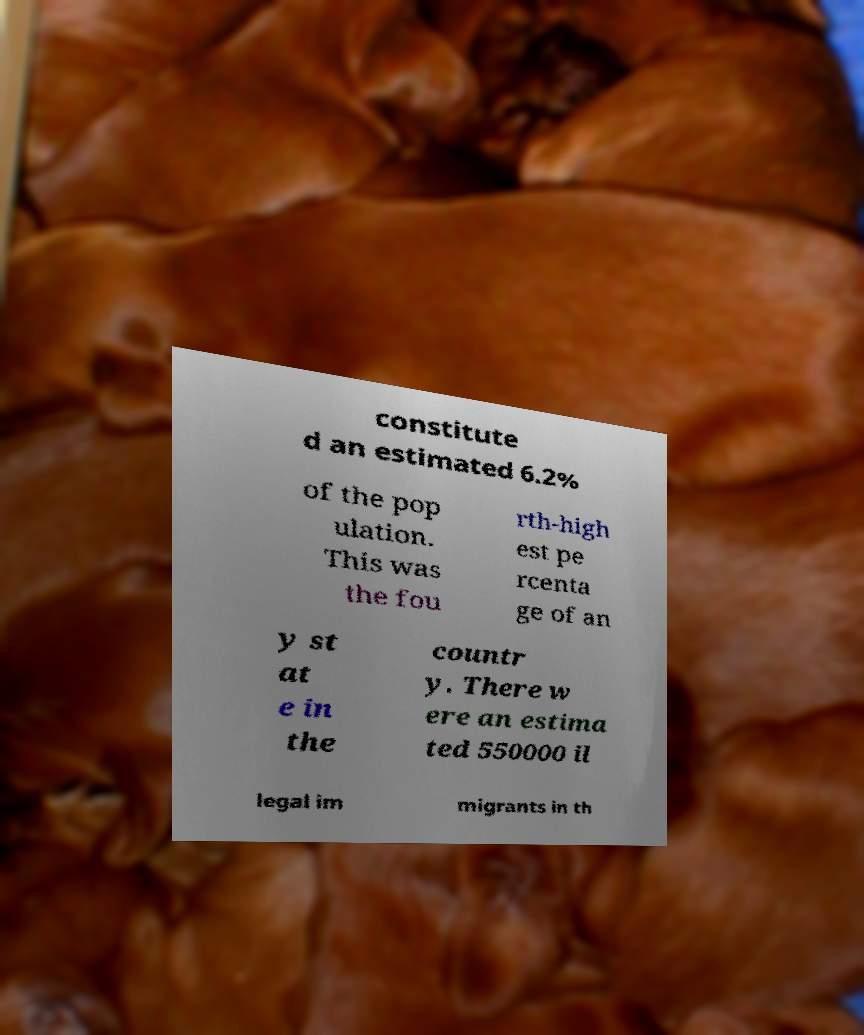Could you assist in decoding the text presented in this image and type it out clearly? constitute d an estimated 6.2% of the pop ulation. This was the fou rth-high est pe rcenta ge of an y st at e in the countr y. There w ere an estima ted 550000 il legal im migrants in th 